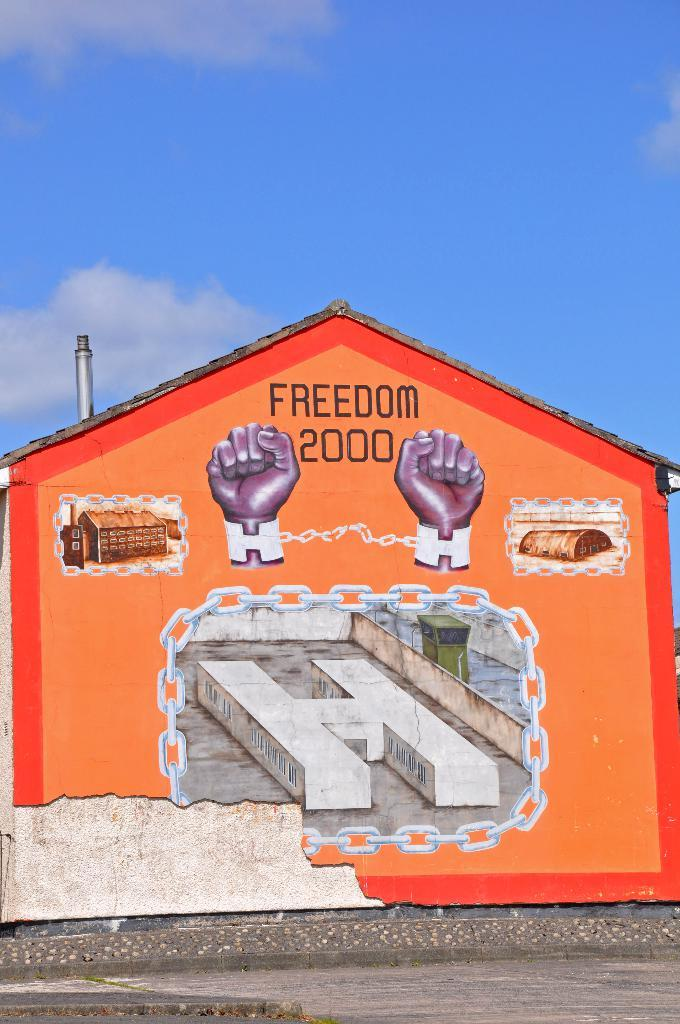What type of structure is in the image? There is a shed in the image. What is on the wall of the shed? There is a painting on the wall of the shed. What can be seen at the top of the image? The sky is visible at the top of the image. What is present in the sky? Clouds are present in the sky. Where is the mine located in the image? There is no mine present in the image. What type of leaf is falling from the tree in the image? There is no tree or leaf present in the image. 